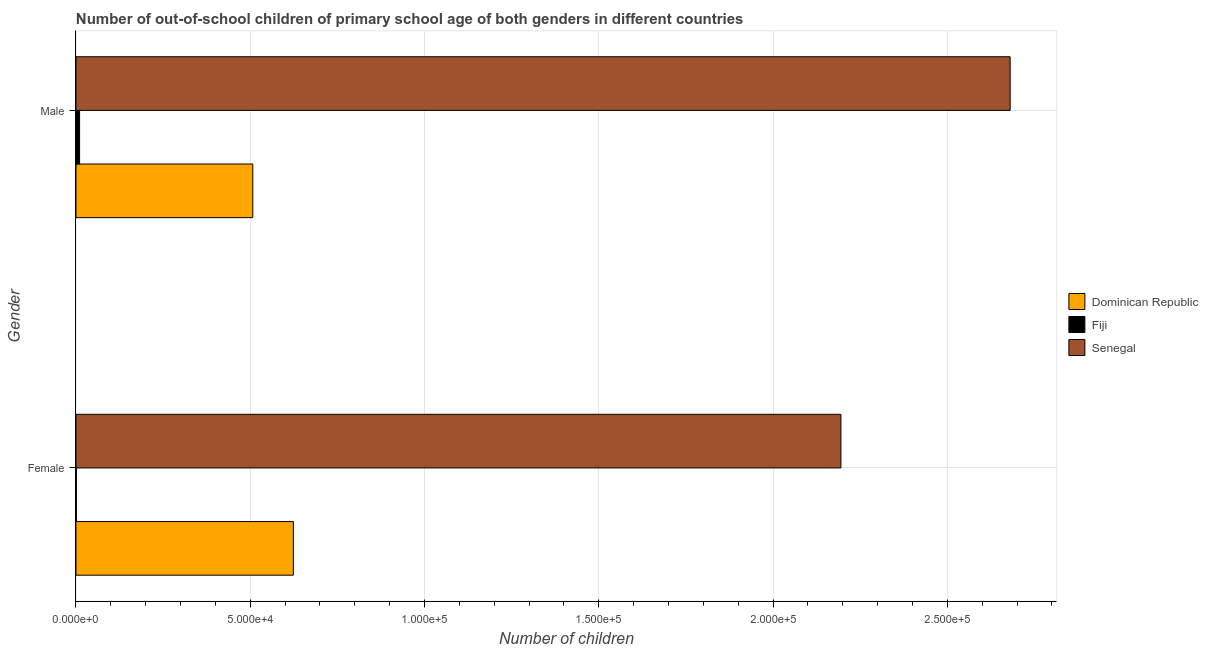How many groups of bars are there?
Provide a succinct answer. 2. How many bars are there on the 2nd tick from the top?
Provide a succinct answer. 3. What is the number of female out-of-school students in Senegal?
Give a very brief answer. 2.19e+05. Across all countries, what is the maximum number of male out-of-school students?
Give a very brief answer. 2.68e+05. Across all countries, what is the minimum number of male out-of-school students?
Make the answer very short. 1036. In which country was the number of female out-of-school students maximum?
Ensure brevity in your answer.  Senegal. In which country was the number of male out-of-school students minimum?
Give a very brief answer. Fiji. What is the total number of female out-of-school students in the graph?
Provide a short and direct response. 2.82e+05. What is the difference between the number of female out-of-school students in Fiji and that in Dominican Republic?
Offer a terse response. -6.23e+04. What is the difference between the number of male out-of-school students in Dominican Republic and the number of female out-of-school students in Senegal?
Provide a short and direct response. -1.69e+05. What is the average number of male out-of-school students per country?
Ensure brevity in your answer.  1.07e+05. What is the difference between the number of female out-of-school students and number of male out-of-school students in Senegal?
Your response must be concise. -4.86e+04. In how many countries, is the number of female out-of-school students greater than 210000 ?
Provide a succinct answer. 1. What is the ratio of the number of female out-of-school students in Dominican Republic to that in Fiji?
Provide a short and direct response. 611.44. Is the number of female out-of-school students in Senegal less than that in Fiji?
Ensure brevity in your answer.  No. What does the 1st bar from the top in Male represents?
Offer a very short reply. Senegal. What does the 3rd bar from the bottom in Male represents?
Provide a short and direct response. Senegal. Are all the bars in the graph horizontal?
Your answer should be very brief. Yes. Are the values on the major ticks of X-axis written in scientific E-notation?
Keep it short and to the point. Yes. What is the title of the graph?
Your response must be concise. Number of out-of-school children of primary school age of both genders in different countries. What is the label or title of the X-axis?
Your answer should be very brief. Number of children. What is the Number of children in Dominican Republic in Female?
Offer a very short reply. 6.24e+04. What is the Number of children in Fiji in Female?
Make the answer very short. 102. What is the Number of children in Senegal in Female?
Your answer should be compact. 2.19e+05. What is the Number of children in Dominican Republic in Male?
Your answer should be very brief. 5.07e+04. What is the Number of children in Fiji in Male?
Make the answer very short. 1036. What is the Number of children in Senegal in Male?
Provide a short and direct response. 2.68e+05. Across all Gender, what is the maximum Number of children in Dominican Republic?
Provide a short and direct response. 6.24e+04. Across all Gender, what is the maximum Number of children of Fiji?
Keep it short and to the point. 1036. Across all Gender, what is the maximum Number of children in Senegal?
Offer a very short reply. 2.68e+05. Across all Gender, what is the minimum Number of children of Dominican Republic?
Offer a terse response. 5.07e+04. Across all Gender, what is the minimum Number of children of Fiji?
Give a very brief answer. 102. Across all Gender, what is the minimum Number of children in Senegal?
Keep it short and to the point. 2.19e+05. What is the total Number of children of Dominican Republic in the graph?
Give a very brief answer. 1.13e+05. What is the total Number of children in Fiji in the graph?
Your response must be concise. 1138. What is the total Number of children in Senegal in the graph?
Offer a terse response. 4.87e+05. What is the difference between the Number of children of Dominican Republic in Female and that in Male?
Keep it short and to the point. 1.16e+04. What is the difference between the Number of children in Fiji in Female and that in Male?
Your answer should be compact. -934. What is the difference between the Number of children in Senegal in Female and that in Male?
Offer a terse response. -4.86e+04. What is the difference between the Number of children in Dominican Republic in Female and the Number of children in Fiji in Male?
Give a very brief answer. 6.13e+04. What is the difference between the Number of children of Dominican Republic in Female and the Number of children of Senegal in Male?
Provide a short and direct response. -2.06e+05. What is the difference between the Number of children in Fiji in Female and the Number of children in Senegal in Male?
Offer a terse response. -2.68e+05. What is the average Number of children in Dominican Republic per Gender?
Your response must be concise. 5.65e+04. What is the average Number of children of Fiji per Gender?
Provide a short and direct response. 569. What is the average Number of children of Senegal per Gender?
Offer a terse response. 2.44e+05. What is the difference between the Number of children of Dominican Republic and Number of children of Fiji in Female?
Ensure brevity in your answer.  6.23e+04. What is the difference between the Number of children in Dominican Republic and Number of children in Senegal in Female?
Make the answer very short. -1.57e+05. What is the difference between the Number of children of Fiji and Number of children of Senegal in Female?
Offer a terse response. -2.19e+05. What is the difference between the Number of children of Dominican Republic and Number of children of Fiji in Male?
Provide a short and direct response. 4.97e+04. What is the difference between the Number of children in Dominican Republic and Number of children in Senegal in Male?
Provide a succinct answer. -2.17e+05. What is the difference between the Number of children in Fiji and Number of children in Senegal in Male?
Make the answer very short. -2.67e+05. What is the ratio of the Number of children in Dominican Republic in Female to that in Male?
Make the answer very short. 1.23. What is the ratio of the Number of children of Fiji in Female to that in Male?
Provide a short and direct response. 0.1. What is the ratio of the Number of children in Senegal in Female to that in Male?
Provide a short and direct response. 0.82. What is the difference between the highest and the second highest Number of children of Dominican Republic?
Offer a terse response. 1.16e+04. What is the difference between the highest and the second highest Number of children of Fiji?
Provide a short and direct response. 934. What is the difference between the highest and the second highest Number of children of Senegal?
Your answer should be compact. 4.86e+04. What is the difference between the highest and the lowest Number of children in Dominican Republic?
Make the answer very short. 1.16e+04. What is the difference between the highest and the lowest Number of children of Fiji?
Provide a short and direct response. 934. What is the difference between the highest and the lowest Number of children of Senegal?
Offer a terse response. 4.86e+04. 